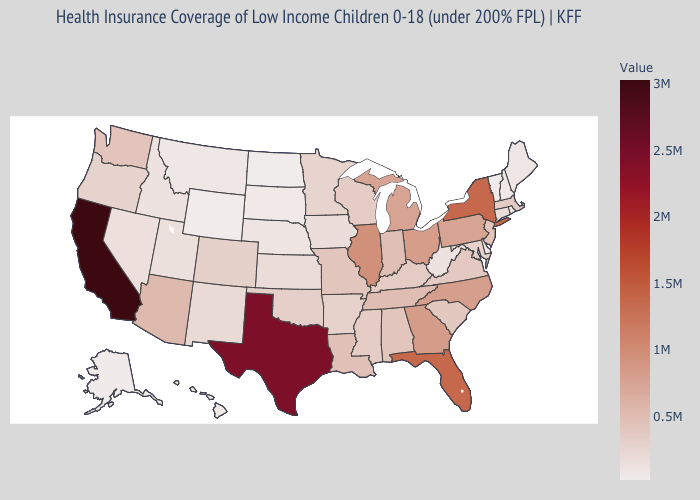Which states have the lowest value in the Northeast?
Answer briefly. Vermont. Does North Dakota have the lowest value in the USA?
Concise answer only. Yes. Which states hav the highest value in the West?
Short answer required. California. Does California have the highest value in the USA?
Answer briefly. Yes. Does Maine have the highest value in the Northeast?
Answer briefly. No. Is the legend a continuous bar?
Quick response, please. Yes. Does the map have missing data?
Be succinct. No. 